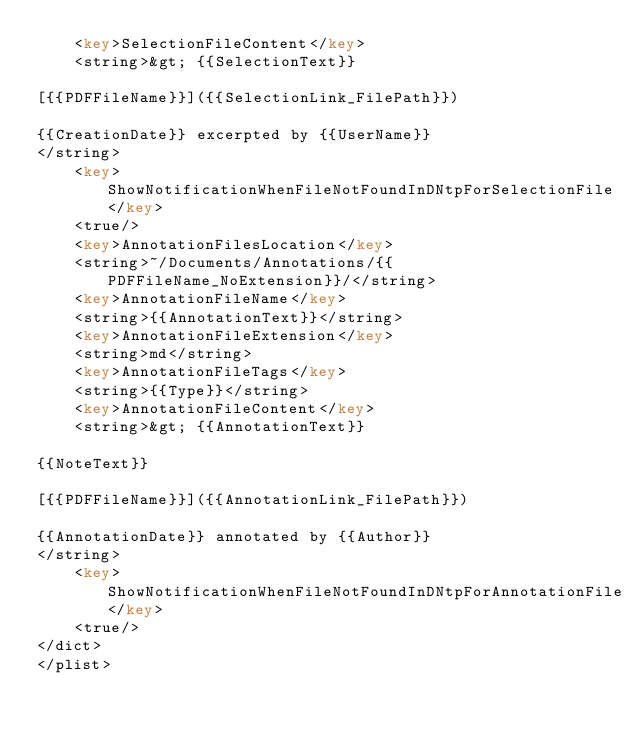Convert code to text. <code><loc_0><loc_0><loc_500><loc_500><_XML_>	<key>SelectionFileContent</key>
	<string>&gt; {{SelectionText}}

[{{PDFFileName}}]({{SelectionLink_FilePath}})

{{CreationDate}} excerpted by {{UserName}}
</string>
	<key>ShowNotificationWhenFileNotFoundInDNtpForSelectionFile</key>
	<true/>
	<key>AnnotationFilesLocation</key>
	<string>~/Documents/Annotations/{{PDFFileName_NoExtension}}/</string>
	<key>AnnotationFileName</key>
	<string>{{AnnotationText}}</string>
	<key>AnnotationFileExtension</key>
	<string>md</string>
	<key>AnnotationFileTags</key>
	<string>{{Type}}</string>
	<key>AnnotationFileContent</key>
	<string>&gt; {{AnnotationText}}

{{NoteText}}

[{{PDFFileName}}]({{AnnotationLink_FilePath}})

{{AnnotationDate}} annotated by {{Author}}
</string>
	<key>ShowNotificationWhenFileNotFoundInDNtpForAnnotationFile</key>
	<true/>
</dict>
</plist>
</code> 